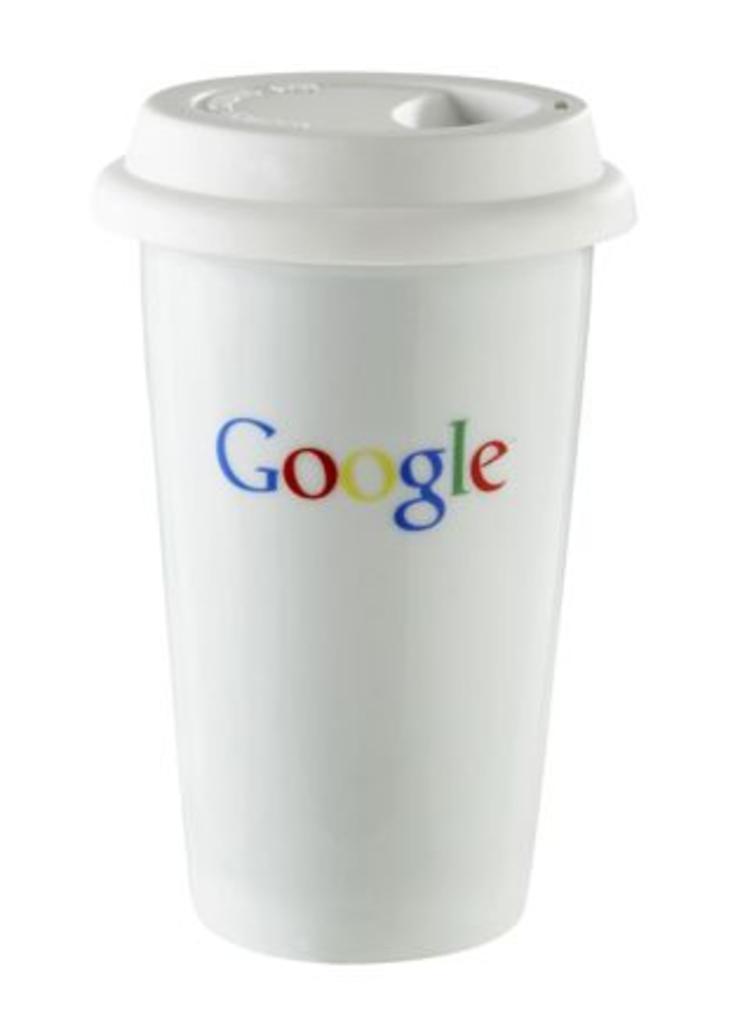Can you describe this image briefly? This is a white cup with lid. On this white cup there is a google logo. 